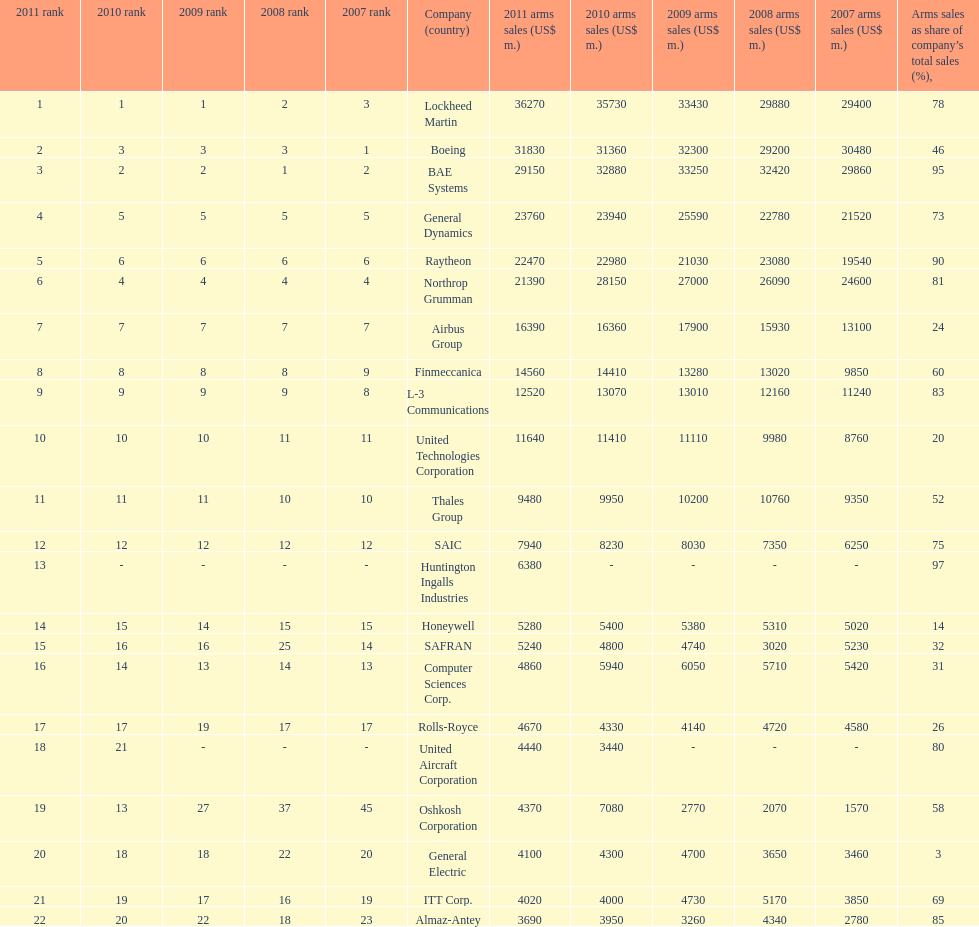In 2010, who recorded the lowest sales figures? United Aircraft Corporation. 